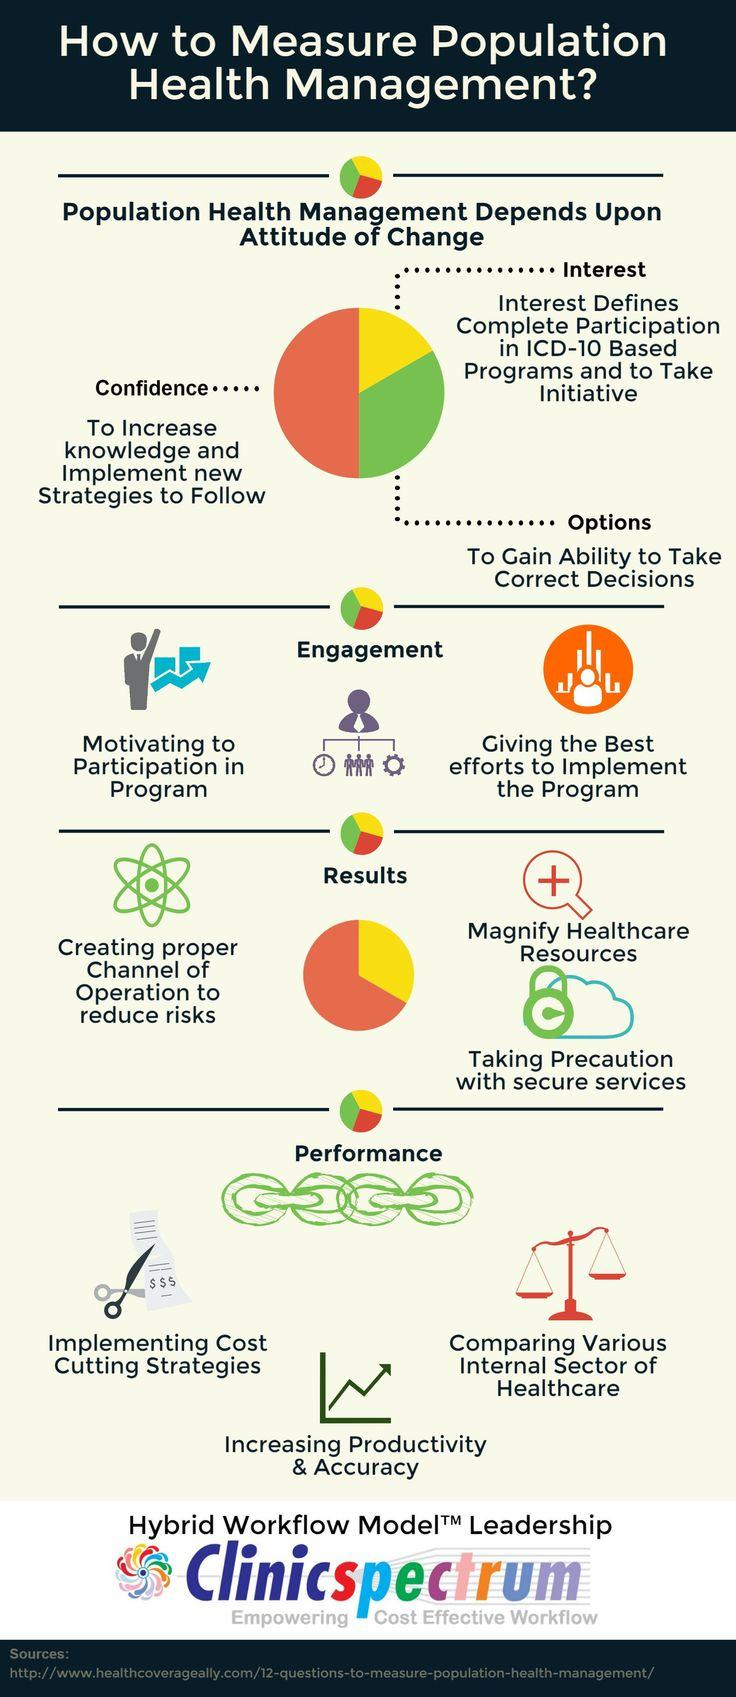Draw attention to some important aspects in this diagram. According to research, the attitude of change towards population health management is primarily contributed by confidence, which accounts for 50% of its overall effectiveness. 